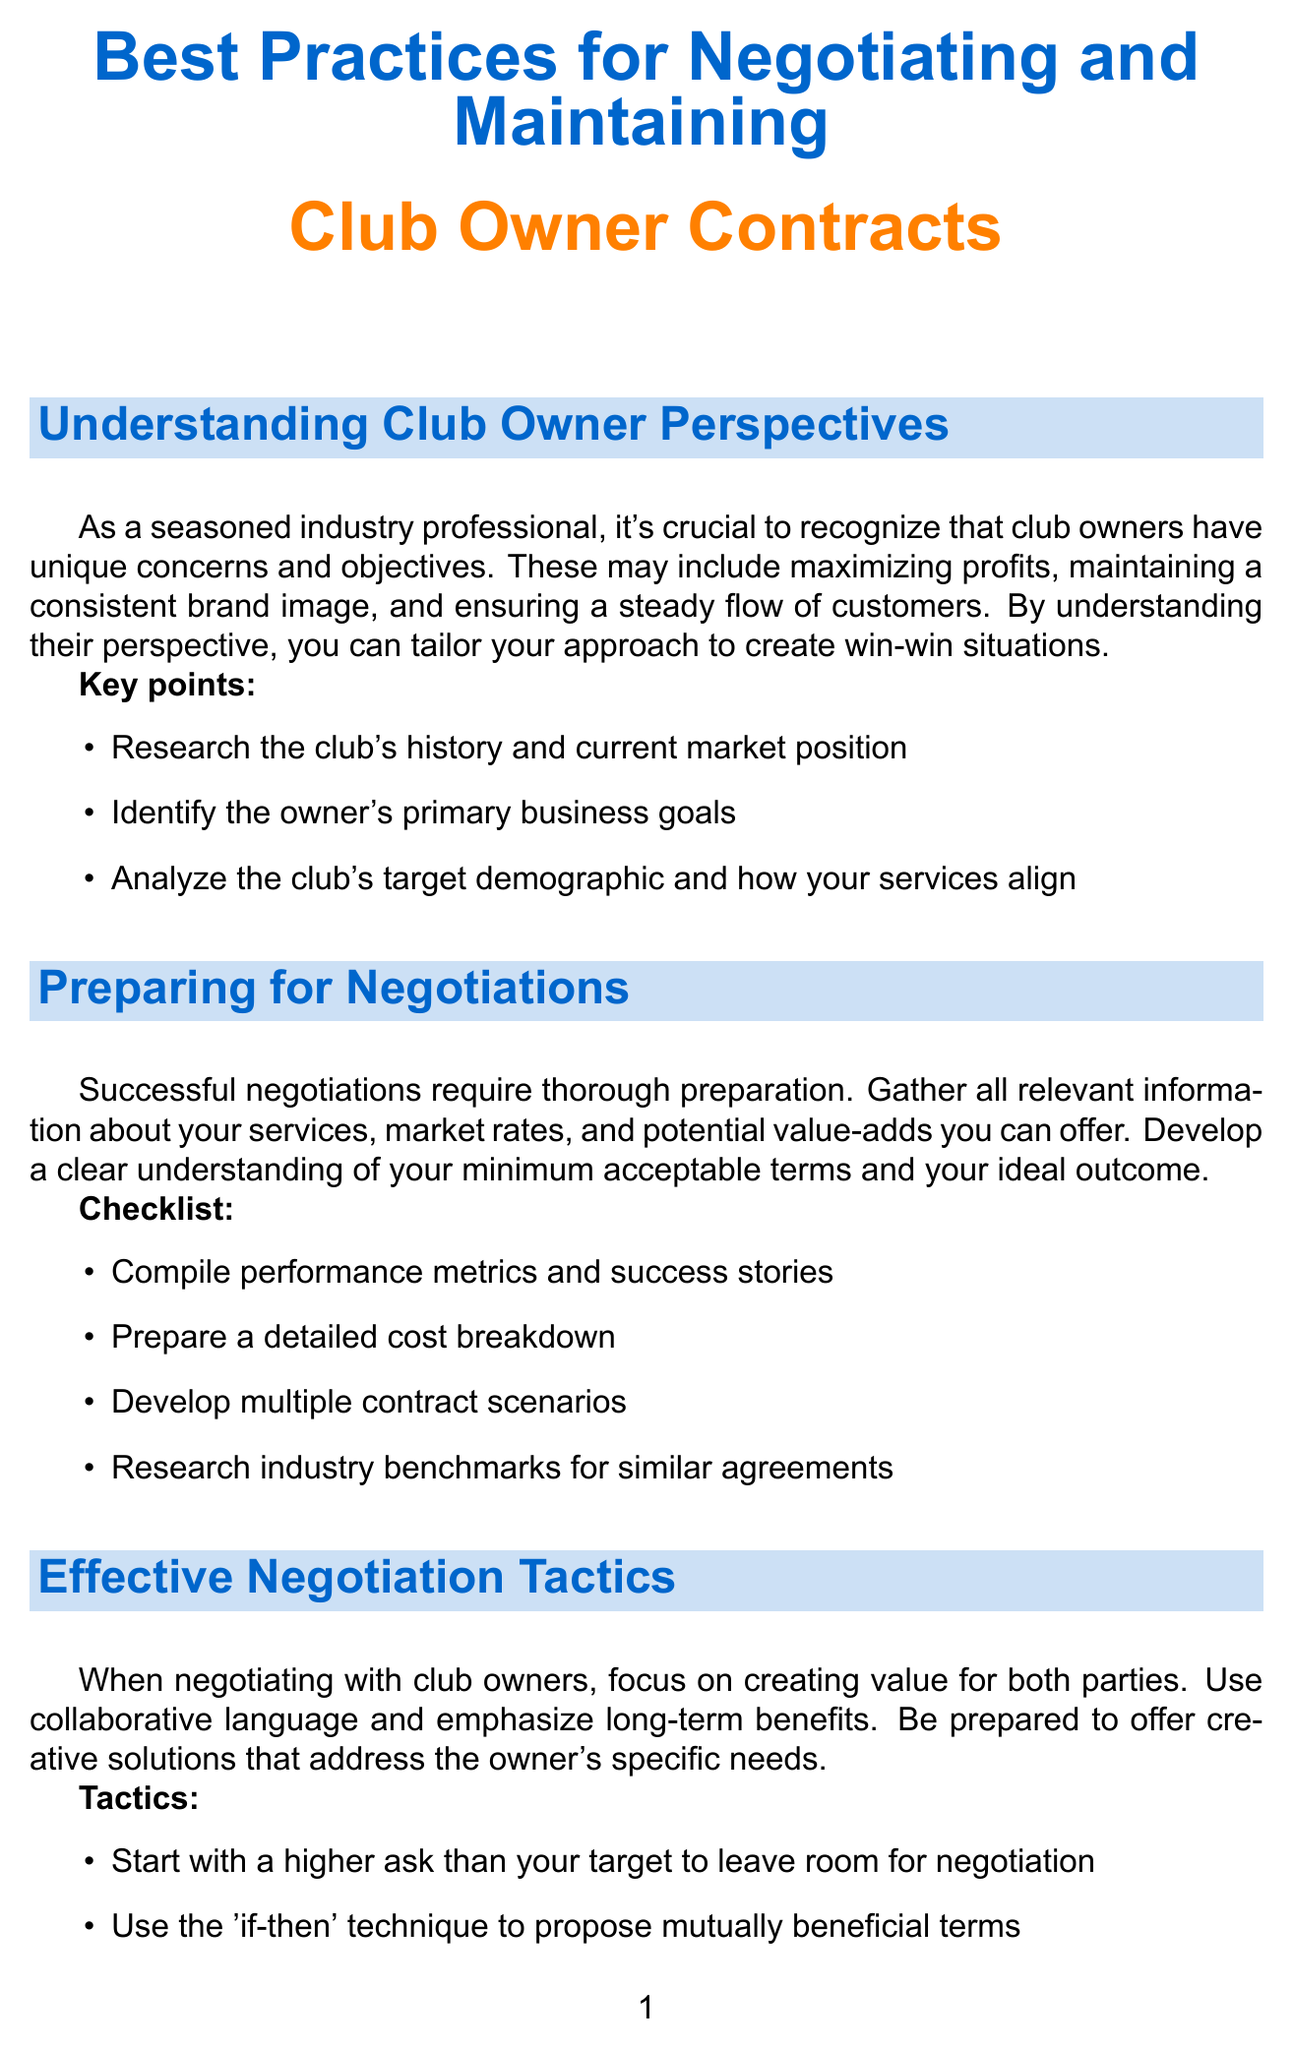What are club owners' primary concerns? Club owners have unique concerns that include maximizing profits, maintaining a consistent brand image, and ensuring a steady flow of customers.
Answer: Maximizing profits, maintaining a consistent brand image, and ensuring a steady flow of customers What is one element to include in contracts? Essential components of contracts with club owners include key aspects like scope of services, which define what services will be provided.
Answer: Scope of services What tactic should you use to encourage negotiation? The negotiation tactic advises using silence strategically, which encourages the other party to elaborate on their points.
Answer: Silence strategically What was Marcus Stellar's base rate per night? In the case study, Marcus Stellar negotiated a base rate of two thousand five hundred dollars per night.
Answer: $2,500 What is a recommended technology tool for contract management? One of the recommended tools to leverage for contract management is a software like DocuSign.
Answer: DocuSign How many items are listed in the sample agreement outline? The outline in the document consists of fourteen essential elements to structure a contract.
Answer: 14 What is a strategy for maintaining relationships with club owners? One strategy mentioned for maintaining relationships includes regular check-ins and performance reviews with club owners.
Answer: Regular check-ins and performance reviews Which year was the case study about The Neon Lounge Agreement conducted? The case study regarding the successful contract with The Neon Lounge took place in the year two thousand twenty-two.
Answer: 2022 